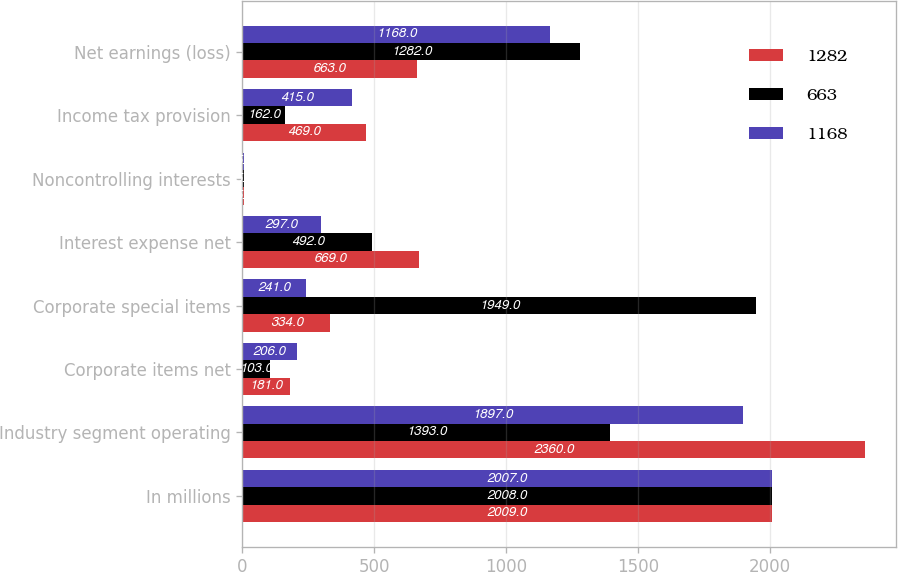Convert chart to OTSL. <chart><loc_0><loc_0><loc_500><loc_500><stacked_bar_chart><ecel><fcel>In millions<fcel>Industry segment operating<fcel>Corporate items net<fcel>Corporate special items<fcel>Interest expense net<fcel>Noncontrolling interests<fcel>Income tax provision<fcel>Net earnings (loss)<nl><fcel>1282<fcel>2009<fcel>2360<fcel>181<fcel>334<fcel>669<fcel>5<fcel>469<fcel>663<nl><fcel>663<fcel>2008<fcel>1393<fcel>103<fcel>1949<fcel>492<fcel>5<fcel>162<fcel>1282<nl><fcel>1168<fcel>2007<fcel>1897<fcel>206<fcel>241<fcel>297<fcel>5<fcel>415<fcel>1168<nl></chart> 